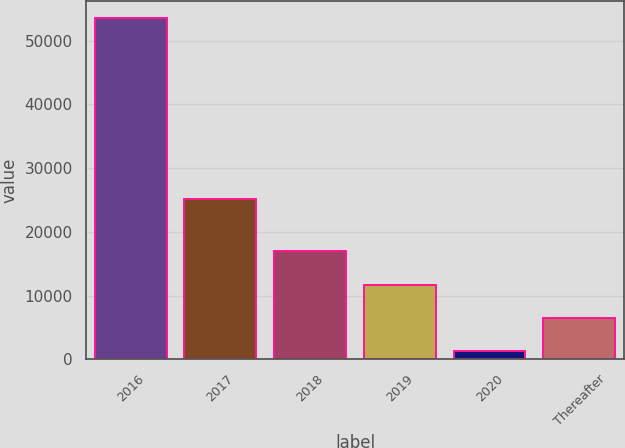Convert chart. <chart><loc_0><loc_0><loc_500><loc_500><bar_chart><fcel>2016<fcel>2017<fcel>2018<fcel>2019<fcel>2020<fcel>Thereafter<nl><fcel>53494<fcel>25114<fcel>16928.8<fcel>11705.2<fcel>1258<fcel>6481.6<nl></chart> 